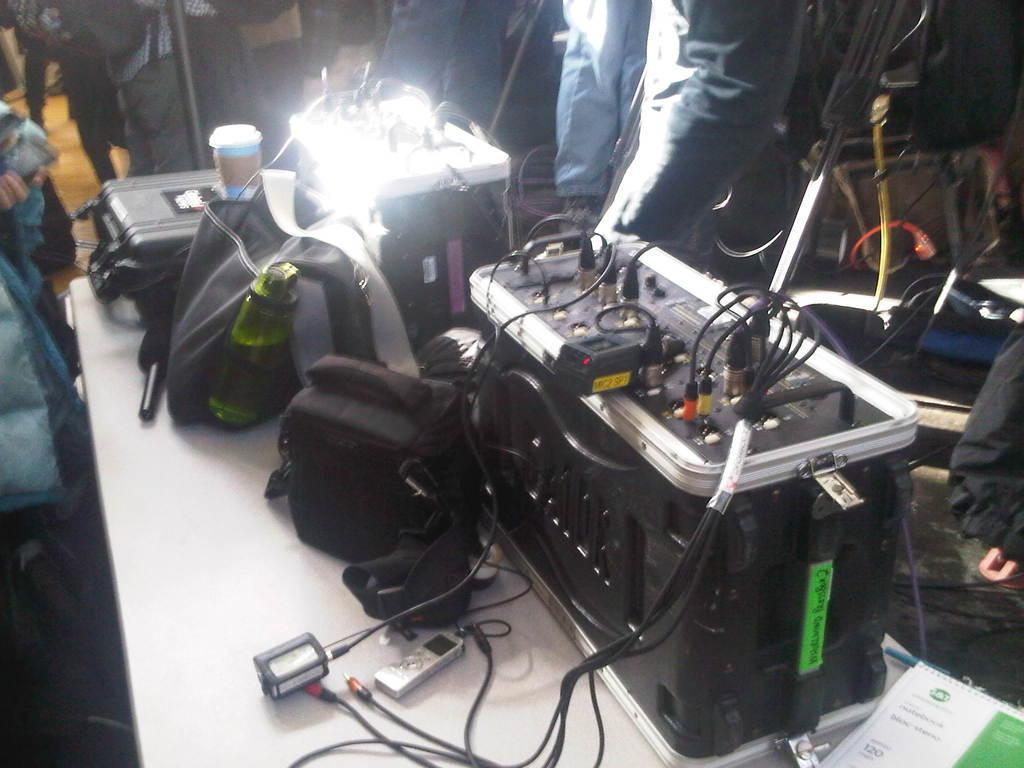Can you describe this image briefly? In the picture we can see a white color desk on it, we can see some box with many switches connected to it and besides it, we can see some bags and some box which is black in color and besides the desk we can see some person sitting and some persons standing opposite to it. 